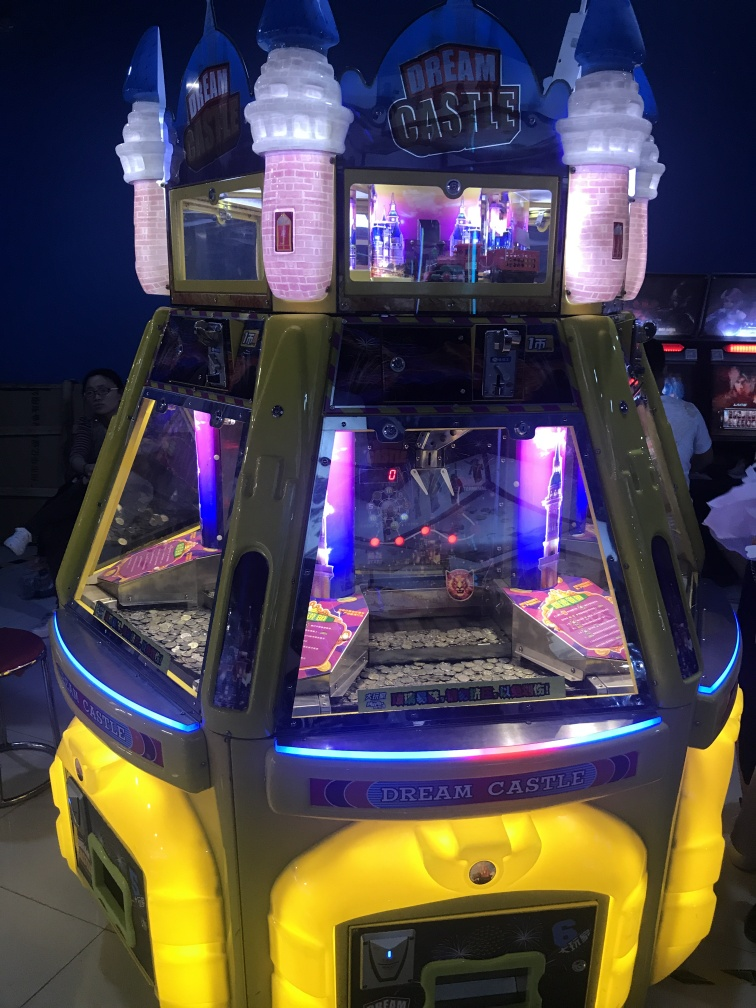Can you guess the target audience for this arcade game based on its appearance? Given the fairy tale castle theme with bright, playful colors and the name 'Dream Castle', this arcade game seems to be targeted primarily at children. Additionally, the fantasy elements and light-hearted design could also make it appealing to families looking for games that are suitable for younger players. What might be the appeal of using a castle theme for an arcade game? A castle theme often resonates with adventure, fantasy, and storytelling, which can be very compelling for an arcade game. It taps into the universal appeal of fairy tales and the thrill of exploration. This theme has the potential to transport players into another world, elevating the gaming experience beyond just winning prizes to one of immersive play and imagination. 